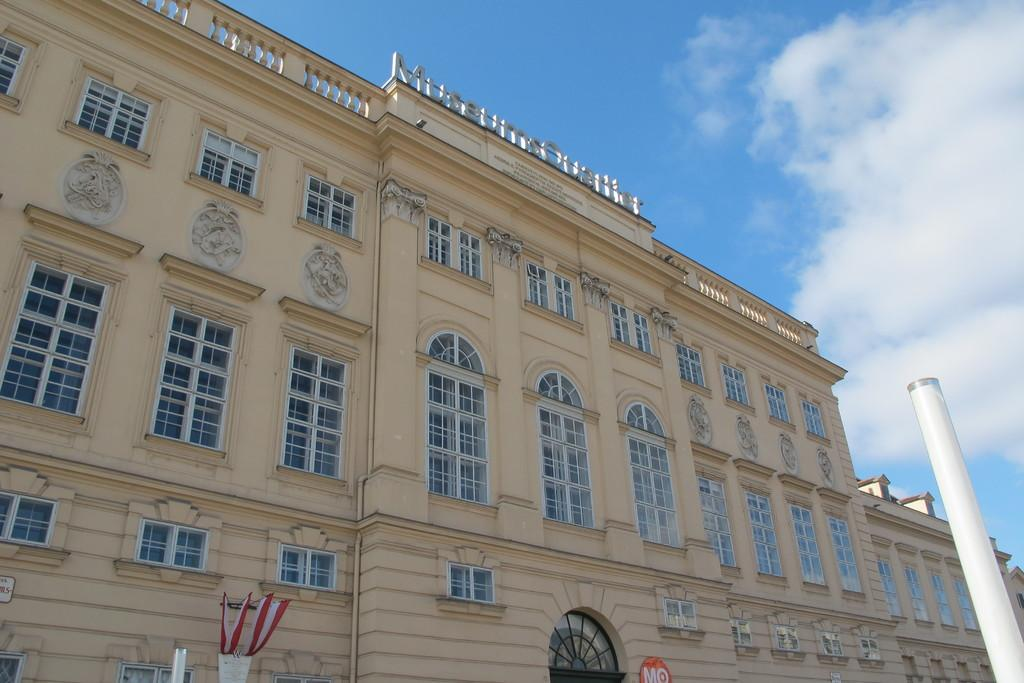What type of structure is present in the image? There is a building in the image. What else can be seen in the image besides the building? There is a pole, a poster, a pot, and some objects in the image. Can you describe the poster in the image? Unfortunately, the facts provided do not give any details about the poster. What is the background of the image? The sky is visible in the background of the image. What song are the horses singing in the image? There are no horses or songs present in the image. How many ducks can be seen swimming in the pot in the image? There are no ducks present in the image, and the pot is not depicted as containing water. 